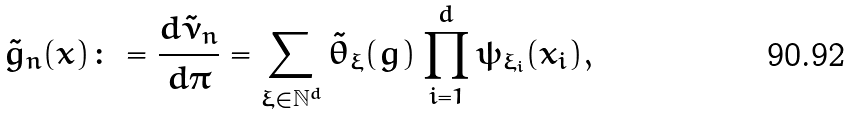<formula> <loc_0><loc_0><loc_500><loc_500>\tilde { g } _ { n } ( x ) \colon = \frac { d \tilde { \nu } _ { n } } { d \pi } = \sum _ { \xi \in \mathbb { N } ^ { d } } \tilde { \theta } _ { \xi } ( g ) \prod _ { i = 1 } ^ { d } \psi _ { \xi _ { i } } ( x _ { i } ) ,</formula> 